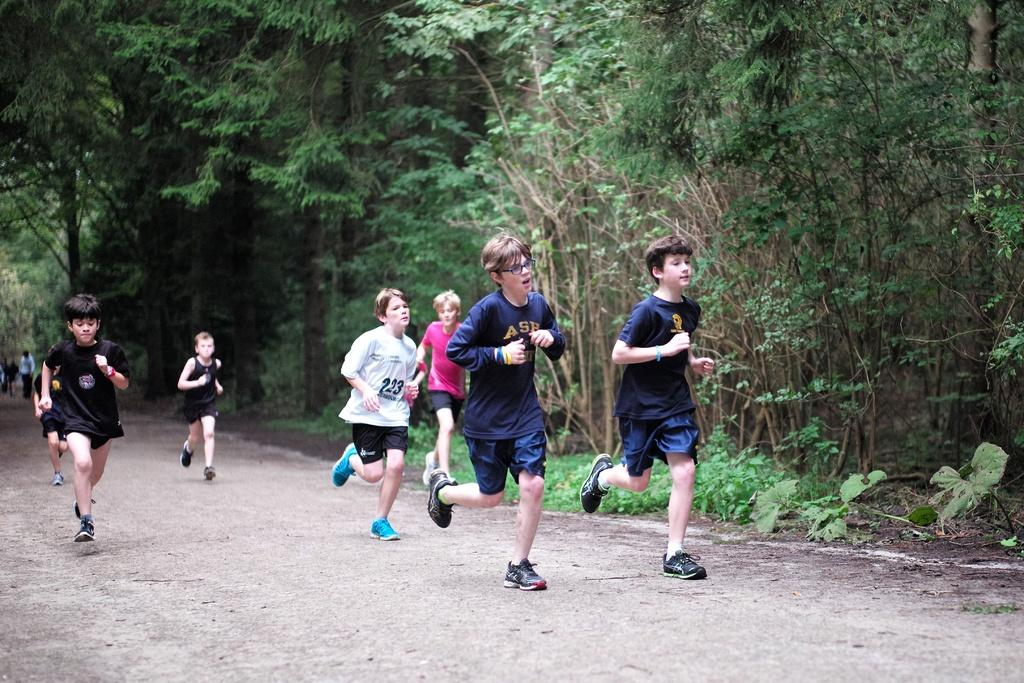What is the main subject of the image? The main subject of the image is a group of children. What are the children doing in the image? The children are running on the road in the image. What can be seen in the background of the image? There is a group of trees and plants visible in the background. What type of coal is being used by the children to fuel their running in the image? There is no coal present in the image, and the children are not using any fuel to run. 